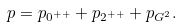<formula> <loc_0><loc_0><loc_500><loc_500>p = p _ { 0 ^ { + + } } + p _ { 2 ^ { + + } } + p _ { G ^ { 2 } } .</formula> 